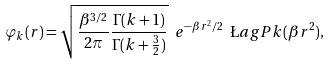<formula> <loc_0><loc_0><loc_500><loc_500>\varphi _ { k } ( r ) = \sqrt { \frac { \beta ^ { 3 / 2 } } { 2 \pi } \frac { \Gamma ( k + 1 ) } { \Gamma ( k + \frac { 3 } { 2 } ) } } \ e ^ { - \beta r ^ { 2 } / 2 } \ \L a g P { k } ( \beta r ^ { 2 } ) ,</formula> 